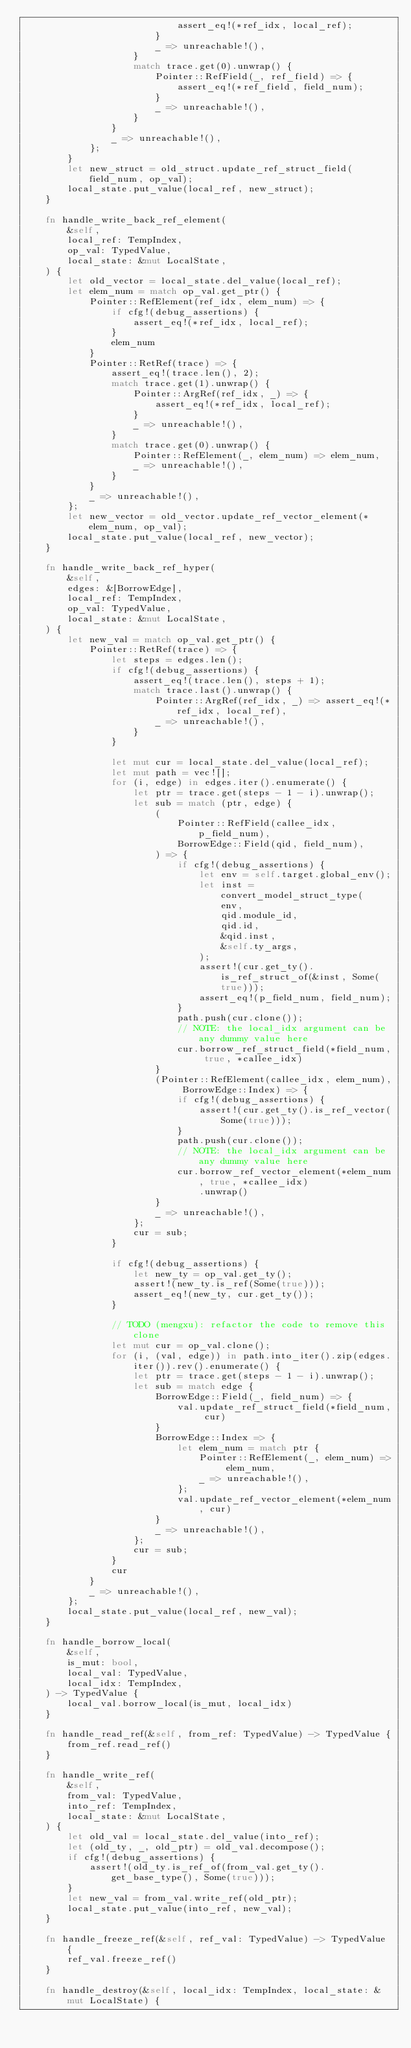<code> <loc_0><loc_0><loc_500><loc_500><_Rust_>                            assert_eq!(*ref_idx, local_ref);
                        }
                        _ => unreachable!(),
                    }
                    match trace.get(0).unwrap() {
                        Pointer::RefField(_, ref_field) => {
                            assert_eq!(*ref_field, field_num);
                        }
                        _ => unreachable!(),
                    }
                }
                _ => unreachable!(),
            };
        }
        let new_struct = old_struct.update_ref_struct_field(field_num, op_val);
        local_state.put_value(local_ref, new_struct);
    }

    fn handle_write_back_ref_element(
        &self,
        local_ref: TempIndex,
        op_val: TypedValue,
        local_state: &mut LocalState,
    ) {
        let old_vector = local_state.del_value(local_ref);
        let elem_num = match op_val.get_ptr() {
            Pointer::RefElement(ref_idx, elem_num) => {
                if cfg!(debug_assertions) {
                    assert_eq!(*ref_idx, local_ref);
                }
                elem_num
            }
            Pointer::RetRef(trace) => {
                assert_eq!(trace.len(), 2);
                match trace.get(1).unwrap() {
                    Pointer::ArgRef(ref_idx, _) => {
                        assert_eq!(*ref_idx, local_ref);
                    }
                    _ => unreachable!(),
                }
                match trace.get(0).unwrap() {
                    Pointer::RefElement(_, elem_num) => elem_num,
                    _ => unreachable!(),
                }
            }
            _ => unreachable!(),
        };
        let new_vector = old_vector.update_ref_vector_element(*elem_num, op_val);
        local_state.put_value(local_ref, new_vector);
    }

    fn handle_write_back_ref_hyper(
        &self,
        edges: &[BorrowEdge],
        local_ref: TempIndex,
        op_val: TypedValue,
        local_state: &mut LocalState,
    ) {
        let new_val = match op_val.get_ptr() {
            Pointer::RetRef(trace) => {
                let steps = edges.len();
                if cfg!(debug_assertions) {
                    assert_eq!(trace.len(), steps + 1);
                    match trace.last().unwrap() {
                        Pointer::ArgRef(ref_idx, _) => assert_eq!(*ref_idx, local_ref),
                        _ => unreachable!(),
                    }
                }

                let mut cur = local_state.del_value(local_ref);
                let mut path = vec![];
                for (i, edge) in edges.iter().enumerate() {
                    let ptr = trace.get(steps - 1 - i).unwrap();
                    let sub = match (ptr, edge) {
                        (
                            Pointer::RefField(callee_idx, p_field_num),
                            BorrowEdge::Field(qid, field_num),
                        ) => {
                            if cfg!(debug_assertions) {
                                let env = self.target.global_env();
                                let inst = convert_model_struct_type(
                                    env,
                                    qid.module_id,
                                    qid.id,
                                    &qid.inst,
                                    &self.ty_args,
                                );
                                assert!(cur.get_ty().is_ref_struct_of(&inst, Some(true)));
                                assert_eq!(p_field_num, field_num);
                            }
                            path.push(cur.clone());
                            // NOTE: the local_idx argument can be any dummy value here
                            cur.borrow_ref_struct_field(*field_num, true, *callee_idx)
                        }
                        (Pointer::RefElement(callee_idx, elem_num), BorrowEdge::Index) => {
                            if cfg!(debug_assertions) {
                                assert!(cur.get_ty().is_ref_vector(Some(true)));
                            }
                            path.push(cur.clone());
                            // NOTE: the local_idx argument can be any dummy value here
                            cur.borrow_ref_vector_element(*elem_num, true, *callee_idx)
                                .unwrap()
                        }
                        _ => unreachable!(),
                    };
                    cur = sub;
                }

                if cfg!(debug_assertions) {
                    let new_ty = op_val.get_ty();
                    assert!(new_ty.is_ref(Some(true)));
                    assert_eq!(new_ty, cur.get_ty());
                }

                // TODO (mengxu): refactor the code to remove this clone
                let mut cur = op_val.clone();
                for (i, (val, edge)) in path.into_iter().zip(edges.iter()).rev().enumerate() {
                    let ptr = trace.get(steps - 1 - i).unwrap();
                    let sub = match edge {
                        BorrowEdge::Field(_, field_num) => {
                            val.update_ref_struct_field(*field_num, cur)
                        }
                        BorrowEdge::Index => {
                            let elem_num = match ptr {
                                Pointer::RefElement(_, elem_num) => elem_num,
                                _ => unreachable!(),
                            };
                            val.update_ref_vector_element(*elem_num, cur)
                        }
                        _ => unreachable!(),
                    };
                    cur = sub;
                }
                cur
            }
            _ => unreachable!(),
        };
        local_state.put_value(local_ref, new_val);
    }

    fn handle_borrow_local(
        &self,
        is_mut: bool,
        local_val: TypedValue,
        local_idx: TempIndex,
    ) -> TypedValue {
        local_val.borrow_local(is_mut, local_idx)
    }

    fn handle_read_ref(&self, from_ref: TypedValue) -> TypedValue {
        from_ref.read_ref()
    }

    fn handle_write_ref(
        &self,
        from_val: TypedValue,
        into_ref: TempIndex,
        local_state: &mut LocalState,
    ) {
        let old_val = local_state.del_value(into_ref);
        let (old_ty, _, old_ptr) = old_val.decompose();
        if cfg!(debug_assertions) {
            assert!(old_ty.is_ref_of(from_val.get_ty().get_base_type(), Some(true)));
        }
        let new_val = from_val.write_ref(old_ptr);
        local_state.put_value(into_ref, new_val);
    }

    fn handle_freeze_ref(&self, ref_val: TypedValue) -> TypedValue {
        ref_val.freeze_ref()
    }

    fn handle_destroy(&self, local_idx: TempIndex, local_state: &mut LocalState) {</code> 